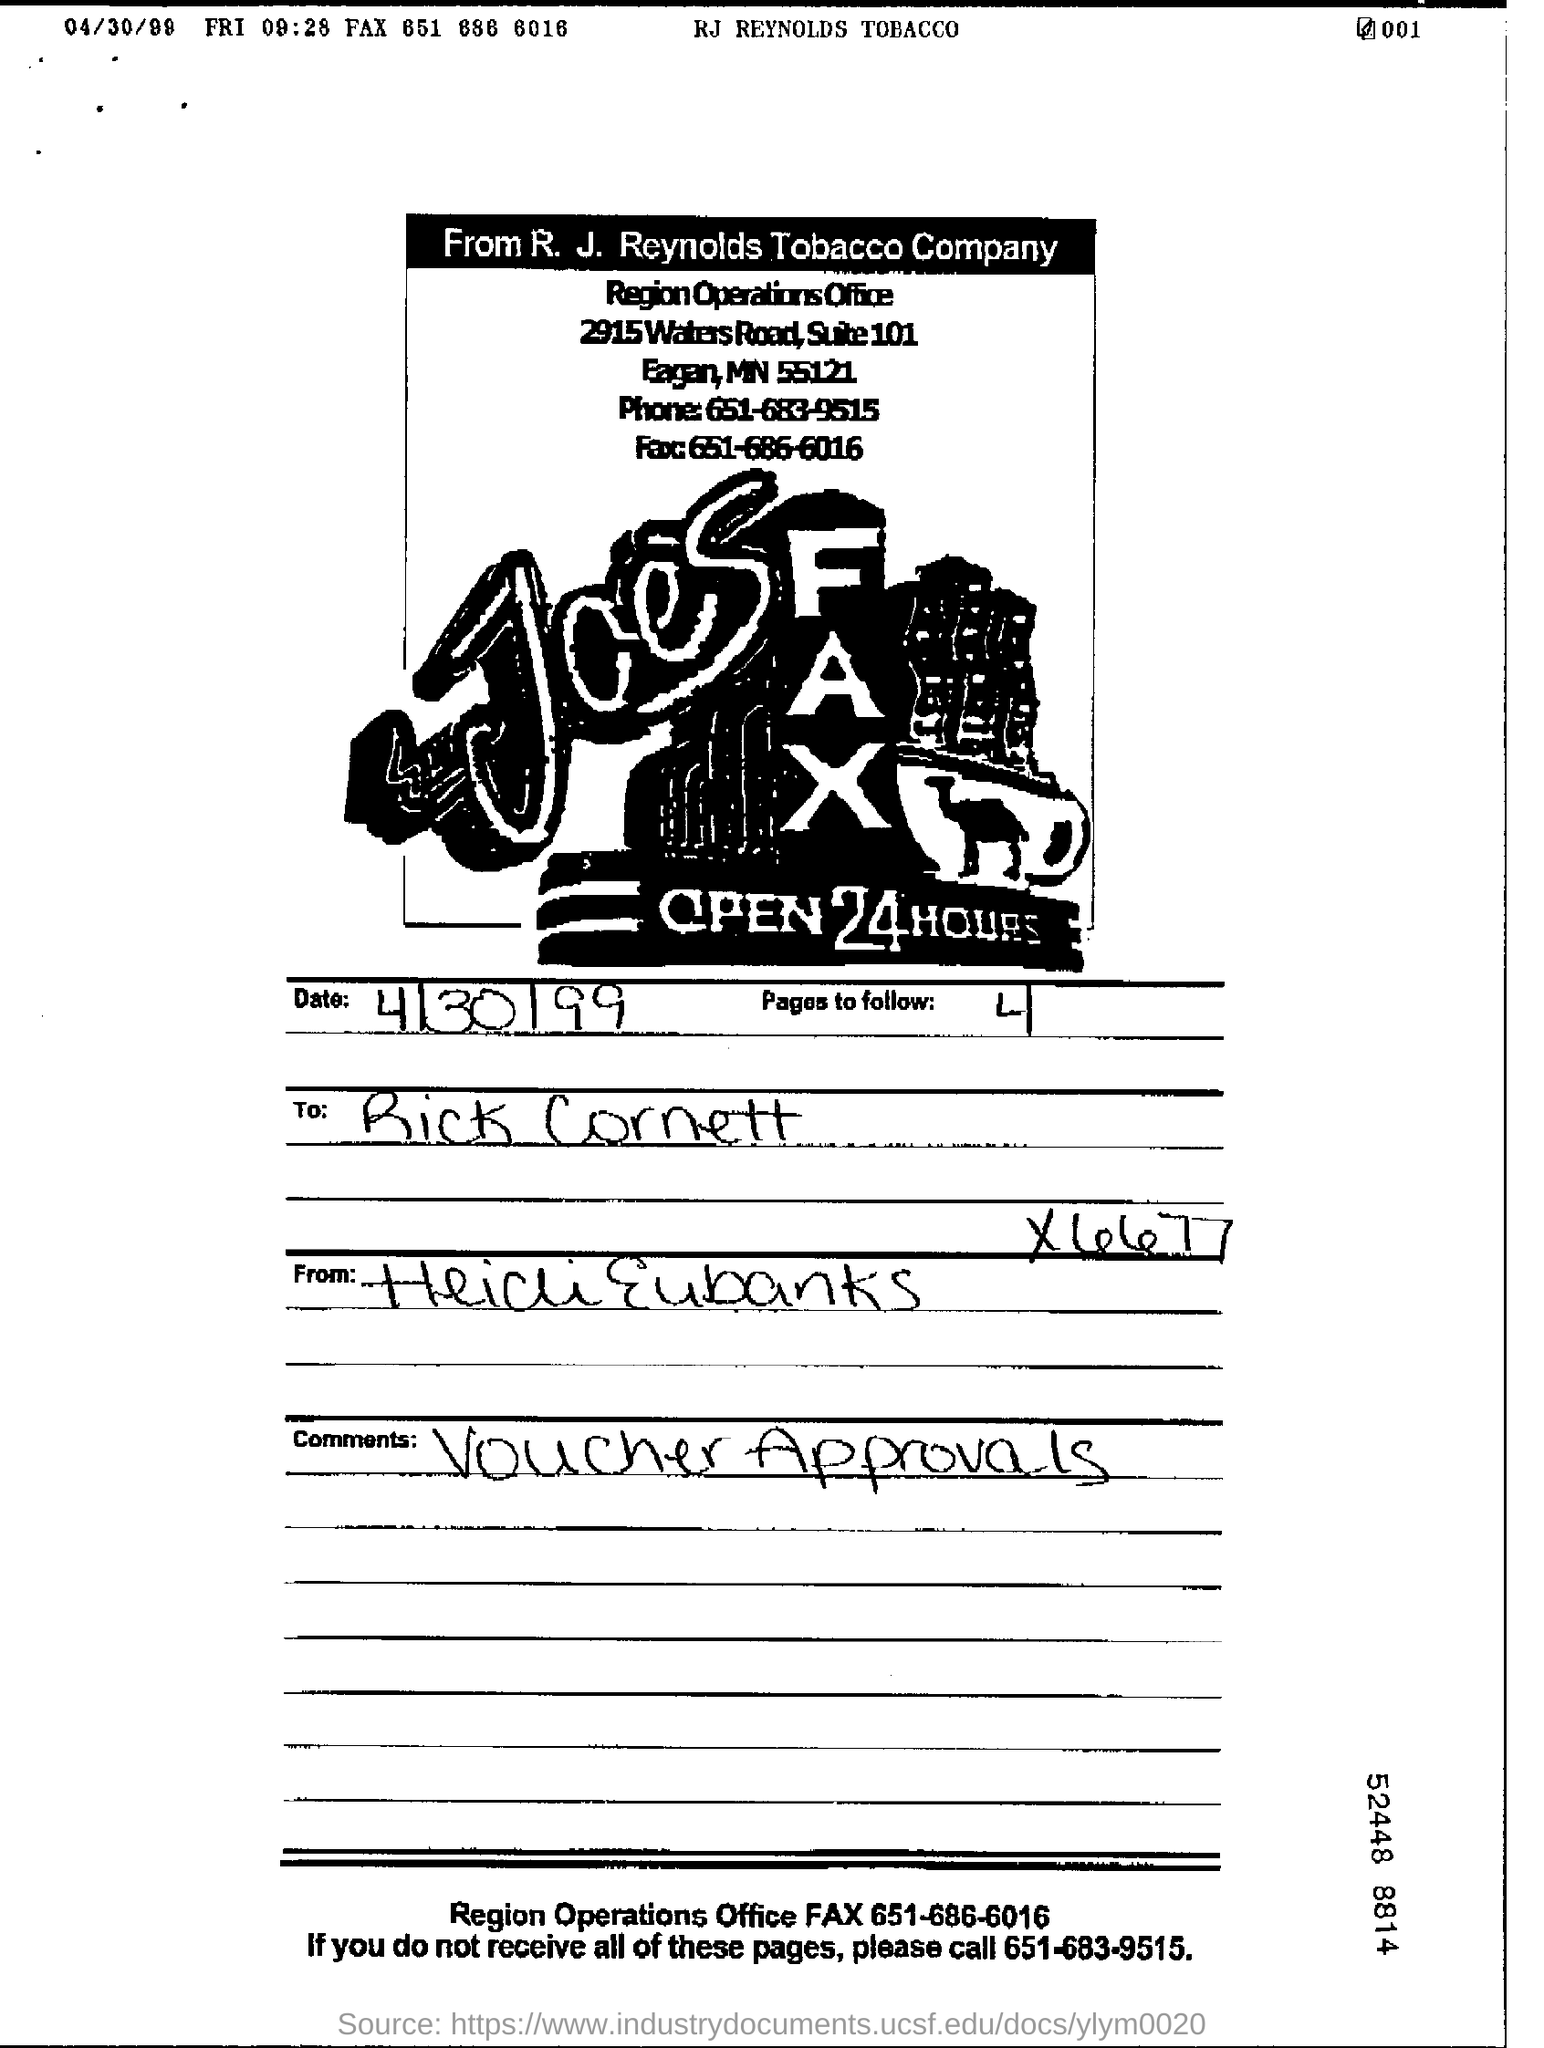When is the document dated?
Your answer should be very brief. 4/30/99. Who is the form addressed to?
Your answer should be very brief. Rick Cornett. What are the written comments?
Offer a terse response. Voucher Approvals. What is the Region Operations Office FAX?
Make the answer very short. 651-686-6016. How many pages to follow?
Your response must be concise. 4. 